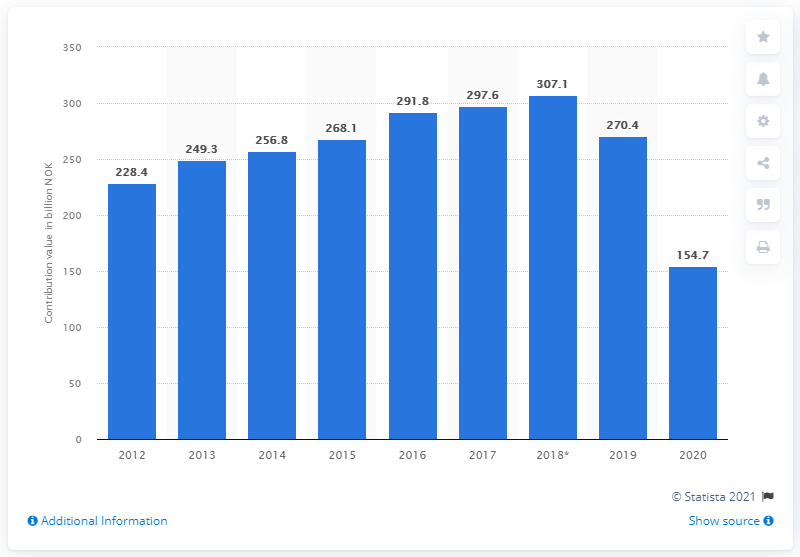List a handful of essential elements in this visual. In 2019, the travel and tourism industry contributed 270.4% to Norway's Gross Domestic Product (GDP). According to statistics, the travel and tourism industry contributed significantly to Norway's Gross Domestic Product in 2020, amounting to 154.7%. 